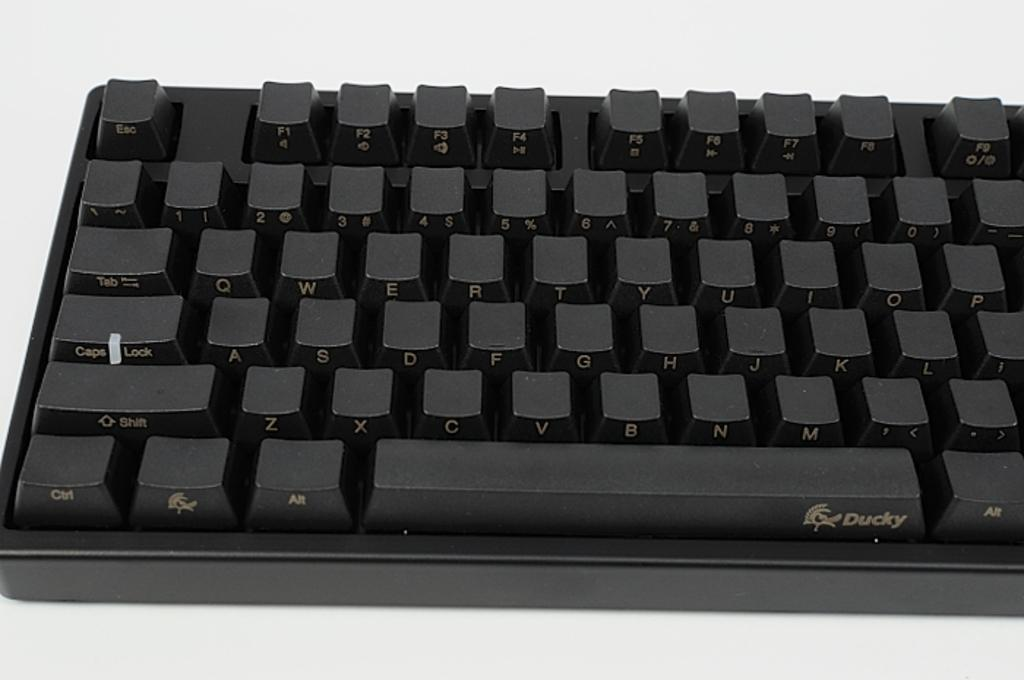<image>
Provide a brief description of the given image. The black keyboard shown is made by the company Ducky. 